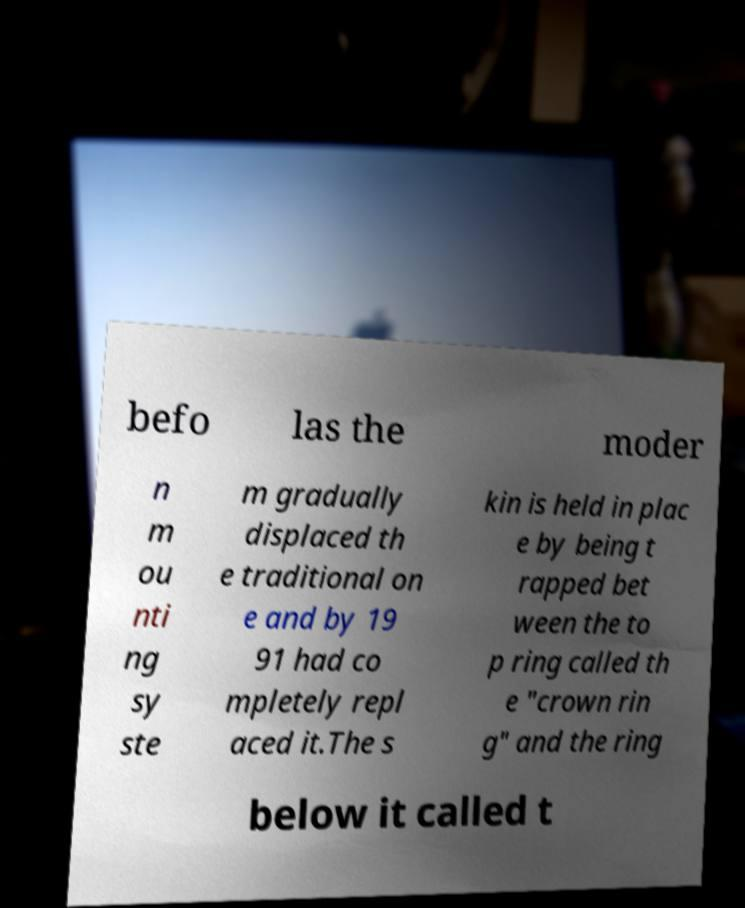Could you assist in decoding the text presented in this image and type it out clearly? befo las the moder n m ou nti ng sy ste m gradually displaced th e traditional on e and by 19 91 had co mpletely repl aced it.The s kin is held in plac e by being t rapped bet ween the to p ring called th e "crown rin g" and the ring below it called t 